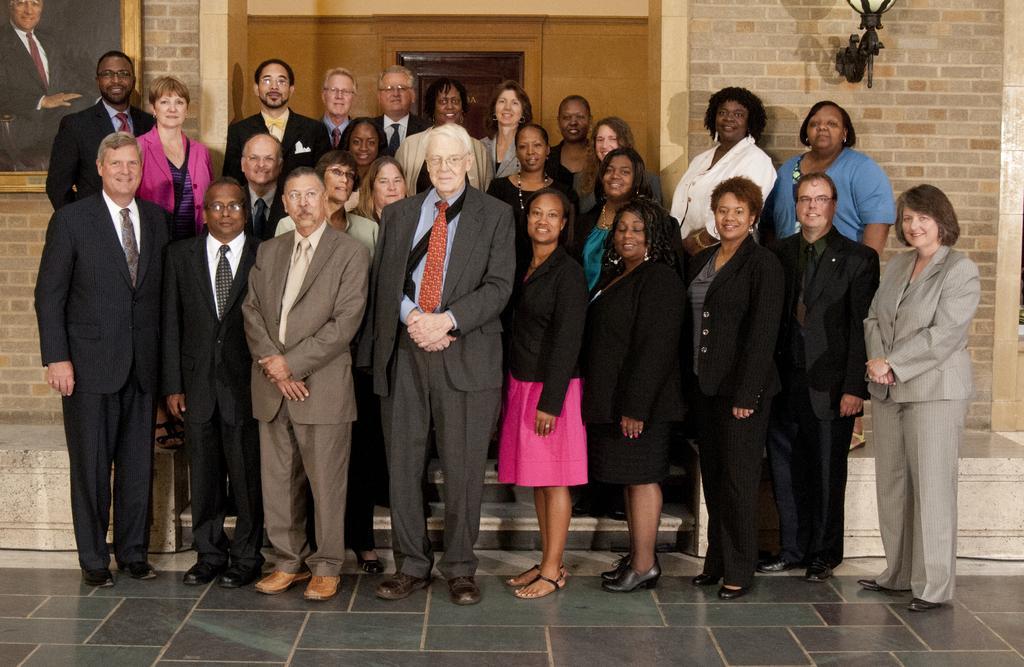Please provide a concise description of this image. In this image in the center there are some persons standing and some of them are wearing bags. In the background there is a photo frame, door, light and wall. At the bottom there is floor. 